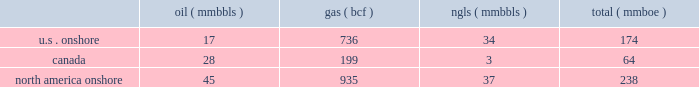Likely than not that some portion or all of the deferred tax assets will not be realized .
The accruals for deferred tax assets and liabilities are subject to a significant amount of judgment by management and are reviewed and adjusted routinely based on changes in facts and circumstances .
Material changes in these accruals may occur in the future , based on the progress of ongoing tax audits , changes in legislation and resolution of pending tax matters .
Forward-looking estimates we are providing our 2011 forward-looking estimates in this section .
These estimates were based on our examination of historical operating trends , the information used to prepare our december 31 , 2010 , reserve reports and other data in our possession or available from third parties .
The forward-looking estimates in this report were prepared assuming demand , curtailment , producibility and general market conditions for our oil , gas and ngls during 2011 will be similar to 2010 , unless otherwise noted .
We make reference to the 201cdisclosure regarding forward-looking statements 201d at the beginning of this report .
Amounts related to our canadian operations have been converted to u.s .
Dollars using an estimated average 2011 exchange rate of $ 0.95 dollar to $ 1.00 canadian dollar .
During 2011 , our operations are substantially comprised of our ongoing north america onshore operations .
We also have international operations in brazil and angola that we are divesting .
We have entered into agreements to sell our assets in brazil for $ 3.2 billion and our assets in angola for $ 70 million , plus contingent consideration .
As a result of these divestitures , all revenues , expenses and capital related to our international operations are reported as discontinued operations in our financial statements .
Additionally , all forward-looking estimates in this document exclude amounts related to our international operations , unless otherwise noted .
North america onshore operating items the following 2011 estimates relate only to our north america onshore assets .
Oil , gas and ngl production set forth below are our estimates of oil , gas and ngl production for 2011 .
We estimate that our combined oil , gas and ngl production will total approximately 236 to 240 mmboe .
( mmbbls ) ( mmbbls ) ( mmboe ) .
Oil and gas prices we expect our 2011 average prices for the oil and gas production from each of our operating areas to differ from the nymex price as set forth in the following table .
The expected ranges for prices are exclusive of the anticipated effects of the financial contracts presented in the 201ccommodity price risk management 201d section below .
The nymex price for oil is determined using the monthly average of settled prices on each trading day for benchmark west texas intermediate crude oil delivered at cushing , oklahoma .
The nymex price for gas is determined using the first-of-month south louisiana henry hub price index as published monthly in inside .
What percentage of total mmboe have come from canada? 
Computations: ((64 / 238) * 100)
Answer: 26.89076. 